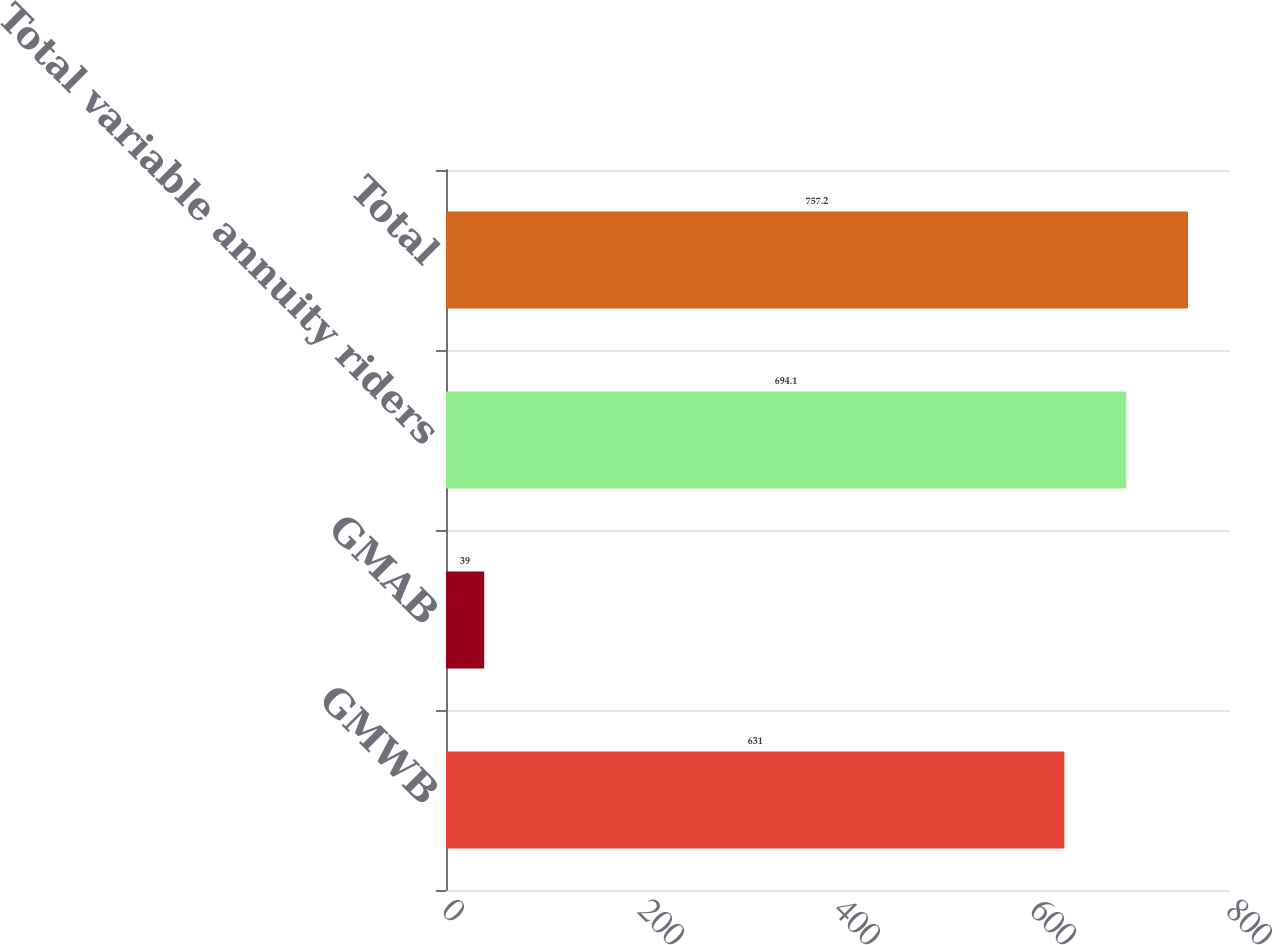Convert chart to OTSL. <chart><loc_0><loc_0><loc_500><loc_500><bar_chart><fcel>GMWB<fcel>GMAB<fcel>Total variable annuity riders<fcel>Total<nl><fcel>631<fcel>39<fcel>694.1<fcel>757.2<nl></chart> 